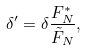<formula> <loc_0><loc_0><loc_500><loc_500>\delta ^ { \prime } = \delta \frac { F ^ { * } _ { N } } { \tilde { F } _ { N } } ,</formula> 